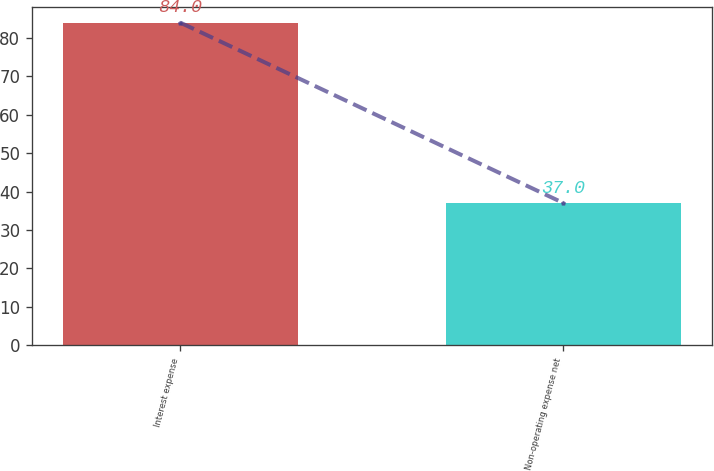<chart> <loc_0><loc_0><loc_500><loc_500><bar_chart><fcel>Interest expense<fcel>Non-operating expense net<nl><fcel>84<fcel>37<nl></chart> 